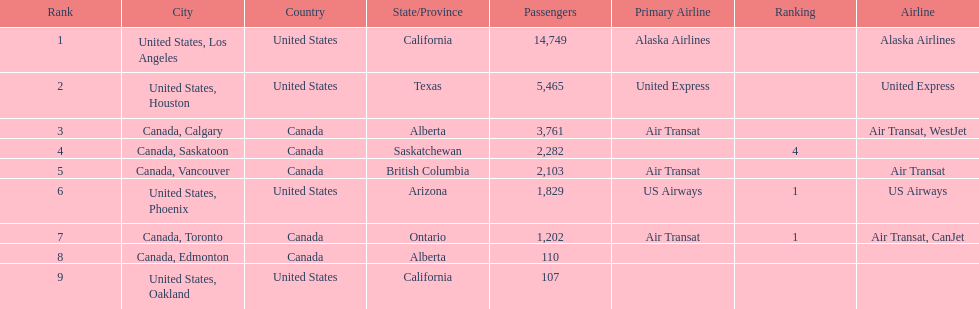How many more passengers flew to los angeles than to saskatoon from manzanillo airport in 2013? 12,467. 